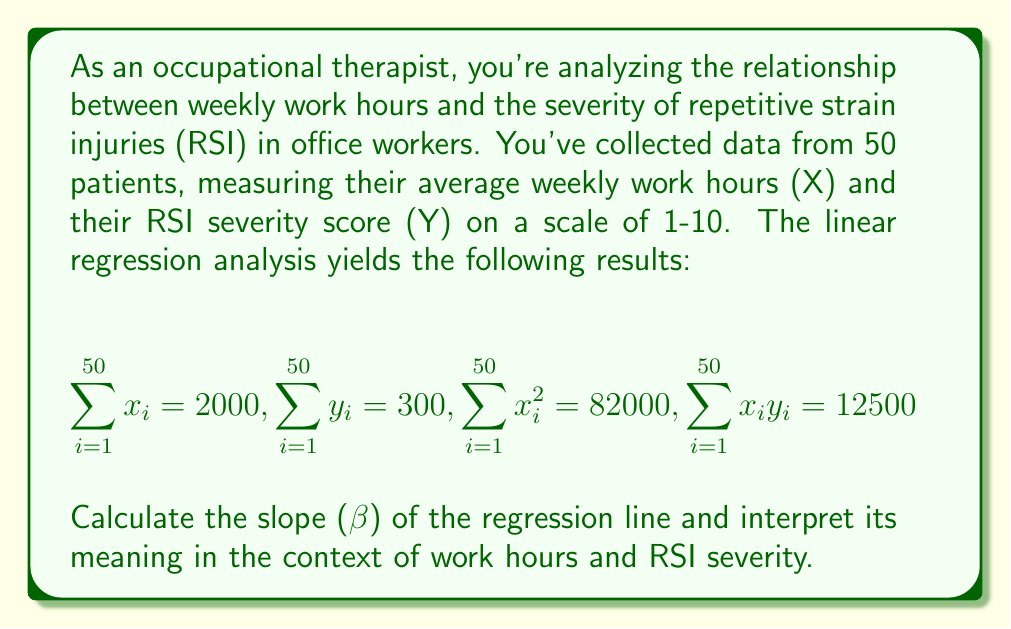What is the answer to this math problem? To calculate the slope (β) of the regression line, we'll use the formula:

$$ \beta = \frac{n\sum x_iy_i - \sum x_i \sum y_i}{n\sum x_i^2 - (\sum x_i)^2} $$

Where:
n = number of data points (50)
$\sum x_iy_i$ = sum of the products of x and y (12500)
$\sum x_i$ = sum of x values (2000)
$\sum y_i$ = sum of y values (300)
$\sum x_i^2$ = sum of squared x values (82000)

Let's substitute these values into the formula:

$$ \beta = \frac{50(12500) - (2000)(300)}{50(82000) - (2000)^2} $$

$$ \beta = \frac{625000 - 600000}{4100000 - 4000000} $$

$$ \beta = \frac{25000}{100000} = 0.25 $$

Interpretation: The slope (β) of 0.25 indicates that for each additional hour of weekly work, the RSI severity score is expected to increase by 0.25 points on average. This suggests a positive correlation between work hours and RSI severity.

In the context of occupational therapy, this means that as employees work longer hours, they are more likely to experience more severe repetitive strain injuries. For every 4 additional hours worked per week, we would expect to see approximately a 1-point increase in the RSI severity score.
Answer: β = 0.25; For each additional weekly work hour, RSI severity increases by 0.25 points on average. 